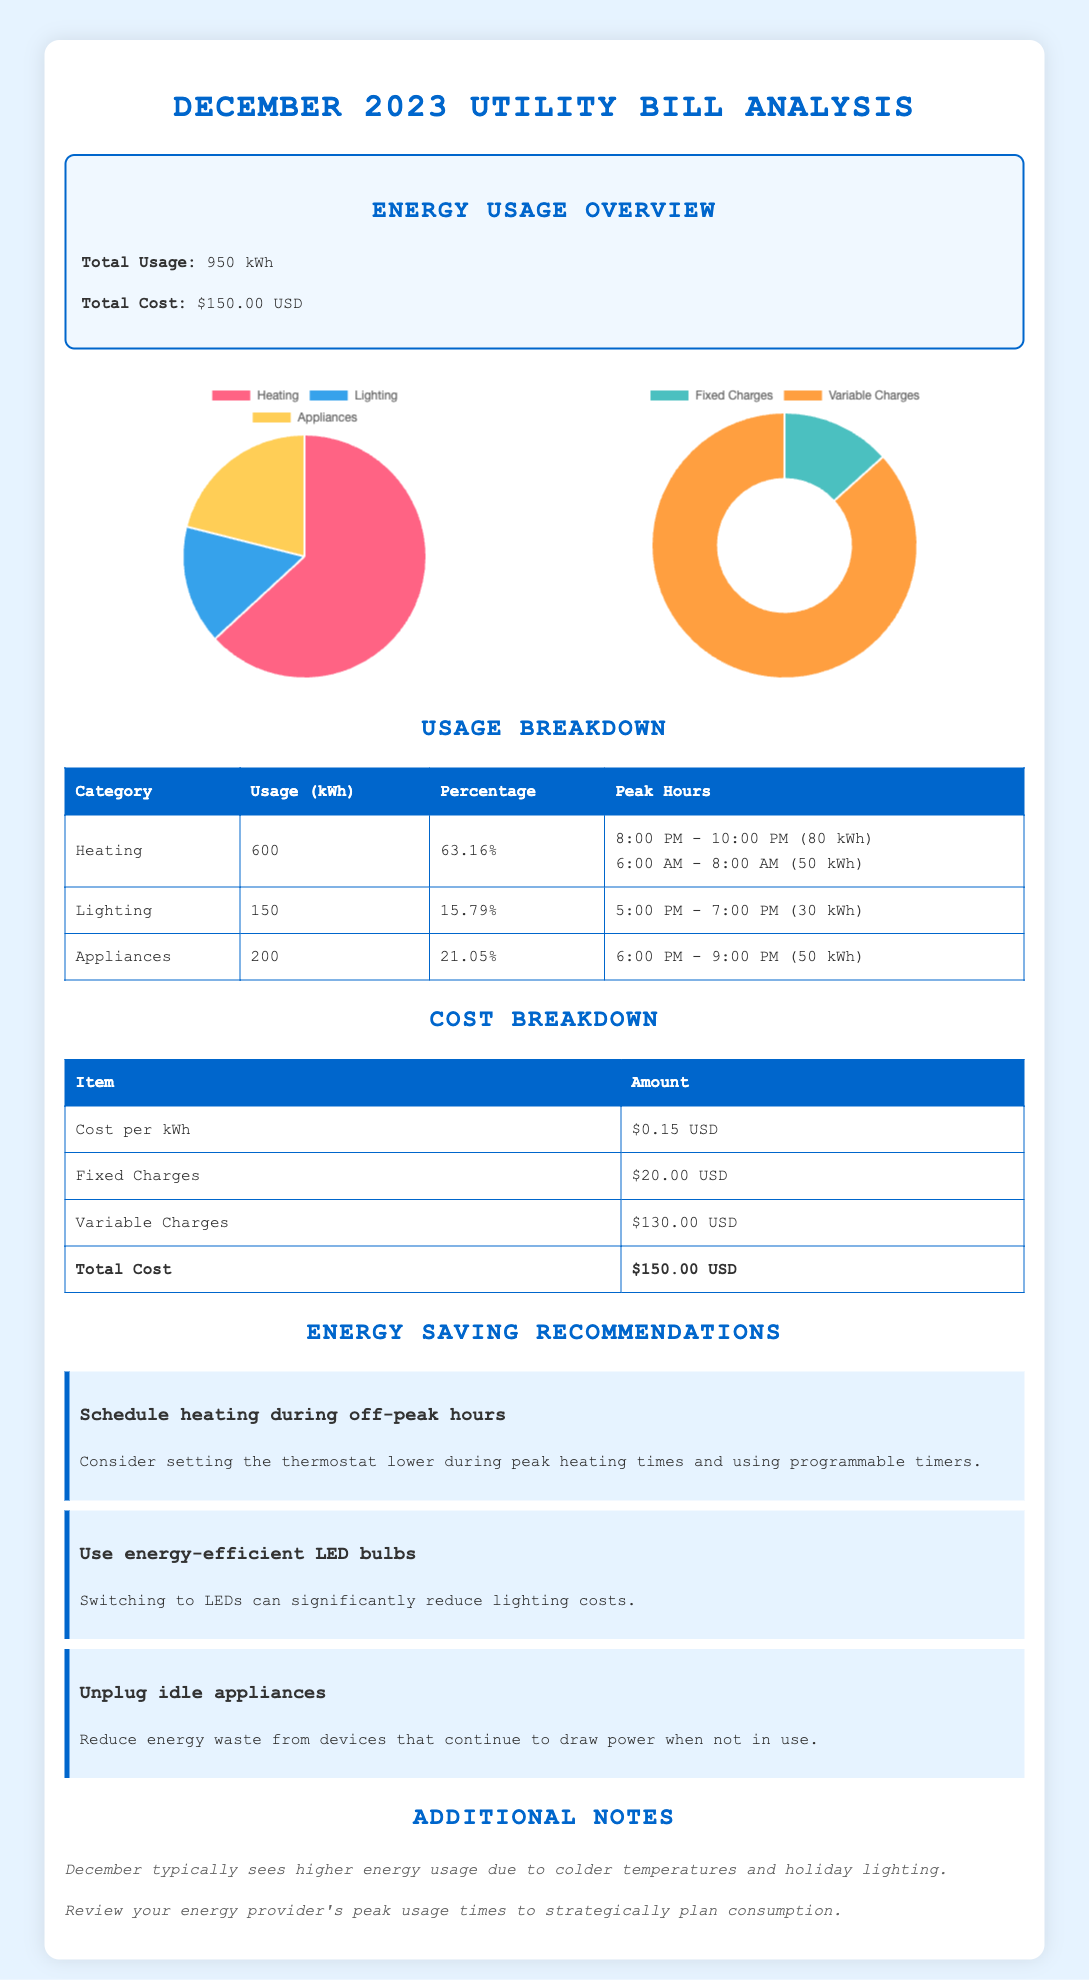what is the total energy usage for December 2023? The total energy usage is specified in the document as 950 kWh.
Answer: 950 kWh what is the total cost for the utility bill in December 2023? The document states that the total cost for December 2023 is $150.00 USD.
Answer: $150.00 USD how much energy was used for heating? The usage breakdown shows that heating used 600 kWh.
Answer: 600 kWh what is the peak hour for lighting energy usage? According to the table, the peak hour for lighting is between 5:00 PM - 7:00 PM.
Answer: 5:00 PM - 7:00 PM what percentage of total usage is attributed to appliances? The document indicates that appliances make up 21.05% of the total energy usage.
Answer: 21.05% how much is charged for fixed charges? The cost breakdown specifies that fixed charges amount to $20.00 USD.
Answer: $20.00 USD what is the recommended energy saving measure related to heating? The document recommends scheduling heating during off-peak hours.
Answer: Schedule heating during off-peak hours how many kWh were used during the peak heating hours? The peak heating hours usage is 80 kWh from 8:00 PM - 10:00 PM and 50 kWh from 6:00 AM - 8:00 AM, totaling 130 kWh.
Answer: 130 kWh what type of document is this? The document is a utility bill analysis for December 2023.
Answer: Utility bill analysis 